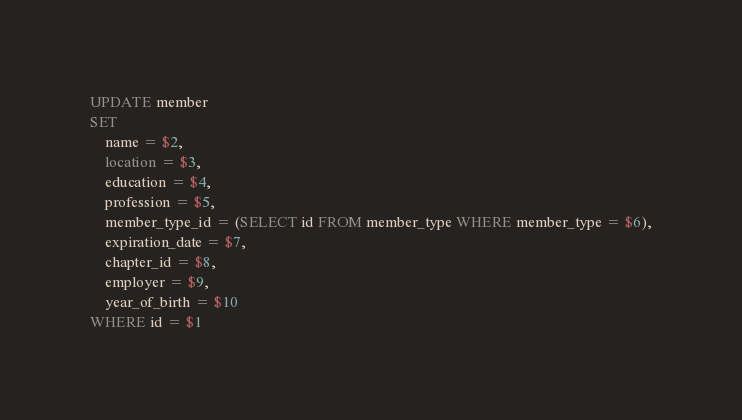<code> <loc_0><loc_0><loc_500><loc_500><_SQL_>UPDATE member
SET
    name = $2,
    location = $3,
    education = $4,
    profession = $5,
    member_type_id = (SELECT id FROM member_type WHERE member_type = $6),
    expiration_date = $7,
    chapter_id = $8,
    employer = $9,
    year_of_birth = $10
WHERE id = $1
</code> 